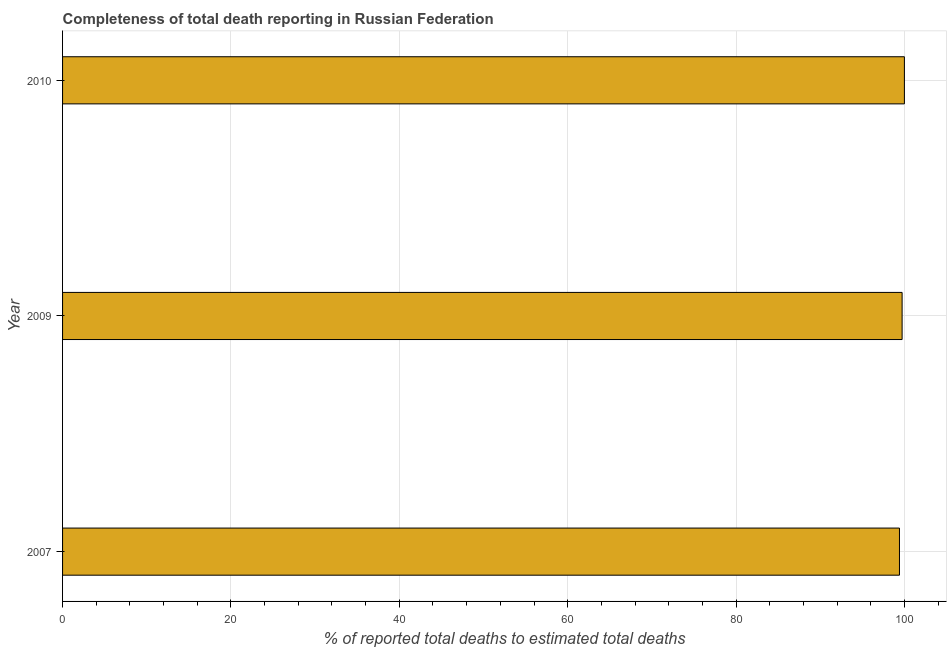Does the graph contain grids?
Your response must be concise. Yes. What is the title of the graph?
Ensure brevity in your answer.  Completeness of total death reporting in Russian Federation. What is the label or title of the X-axis?
Your answer should be very brief. % of reported total deaths to estimated total deaths. What is the completeness of total death reports in 2009?
Offer a very short reply. 99.73. Across all years, what is the minimum completeness of total death reports?
Give a very brief answer. 99.41. In which year was the completeness of total death reports maximum?
Offer a very short reply. 2010. What is the sum of the completeness of total death reports?
Keep it short and to the point. 299.14. What is the difference between the completeness of total death reports in 2009 and 2010?
Make the answer very short. -0.27. What is the average completeness of total death reports per year?
Give a very brief answer. 99.71. What is the median completeness of total death reports?
Give a very brief answer. 99.73. What is the ratio of the completeness of total death reports in 2007 to that in 2010?
Provide a short and direct response. 0.99. Is the completeness of total death reports in 2007 less than that in 2009?
Your answer should be compact. Yes. What is the difference between the highest and the second highest completeness of total death reports?
Your answer should be compact. 0.27. What is the difference between the highest and the lowest completeness of total death reports?
Offer a very short reply. 0.59. What is the % of reported total deaths to estimated total deaths of 2007?
Your answer should be very brief. 99.41. What is the % of reported total deaths to estimated total deaths in 2009?
Offer a terse response. 99.73. What is the % of reported total deaths to estimated total deaths in 2010?
Offer a terse response. 100. What is the difference between the % of reported total deaths to estimated total deaths in 2007 and 2009?
Offer a very short reply. -0.31. What is the difference between the % of reported total deaths to estimated total deaths in 2007 and 2010?
Keep it short and to the point. -0.59. What is the difference between the % of reported total deaths to estimated total deaths in 2009 and 2010?
Offer a terse response. -0.27. 